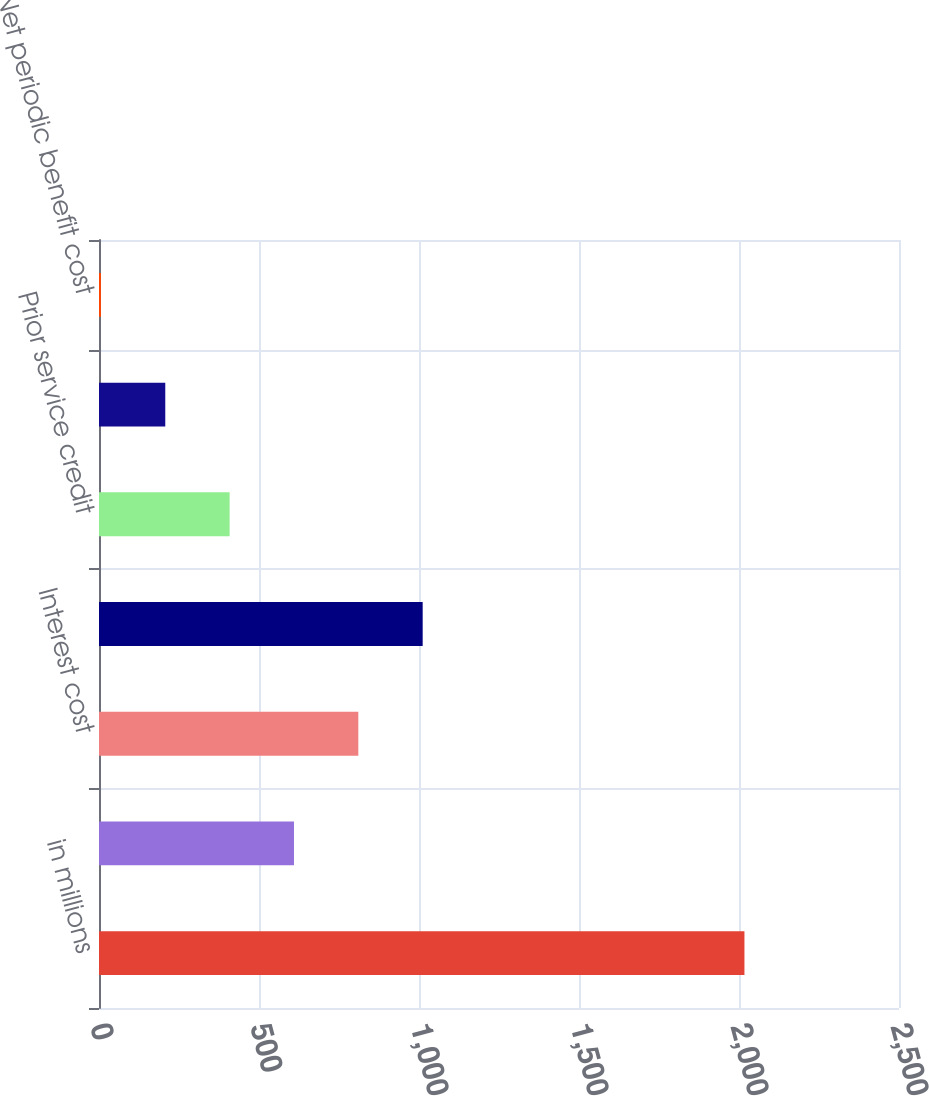Convert chart. <chart><loc_0><loc_0><loc_500><loc_500><bar_chart><fcel>in millions<fcel>Service cost<fcel>Interest cost<fcel>Expected return on plan assets<fcel>Prior service credit<fcel>Net loss from previous years<fcel>Net periodic benefit cost<nl><fcel>2017<fcel>609.3<fcel>810.4<fcel>1011.5<fcel>408.2<fcel>207.1<fcel>6<nl></chart> 